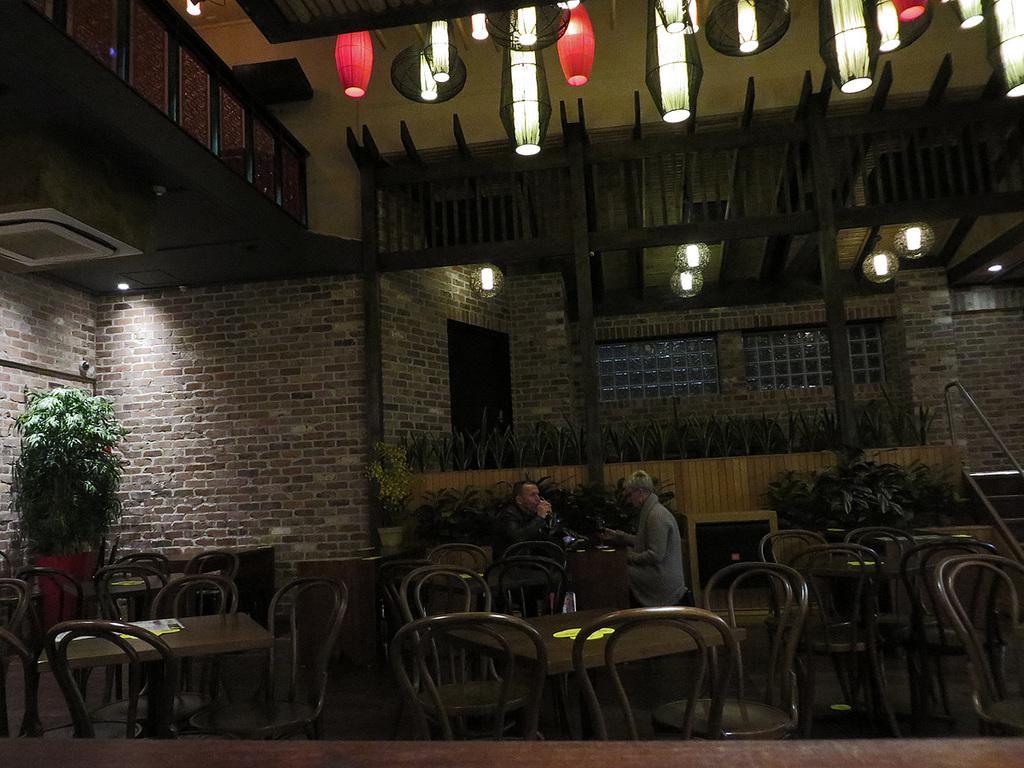Please provide a concise description of this image. In this image I can see a table and two persons sitting on the chair. At the back side there is a flower pot. 